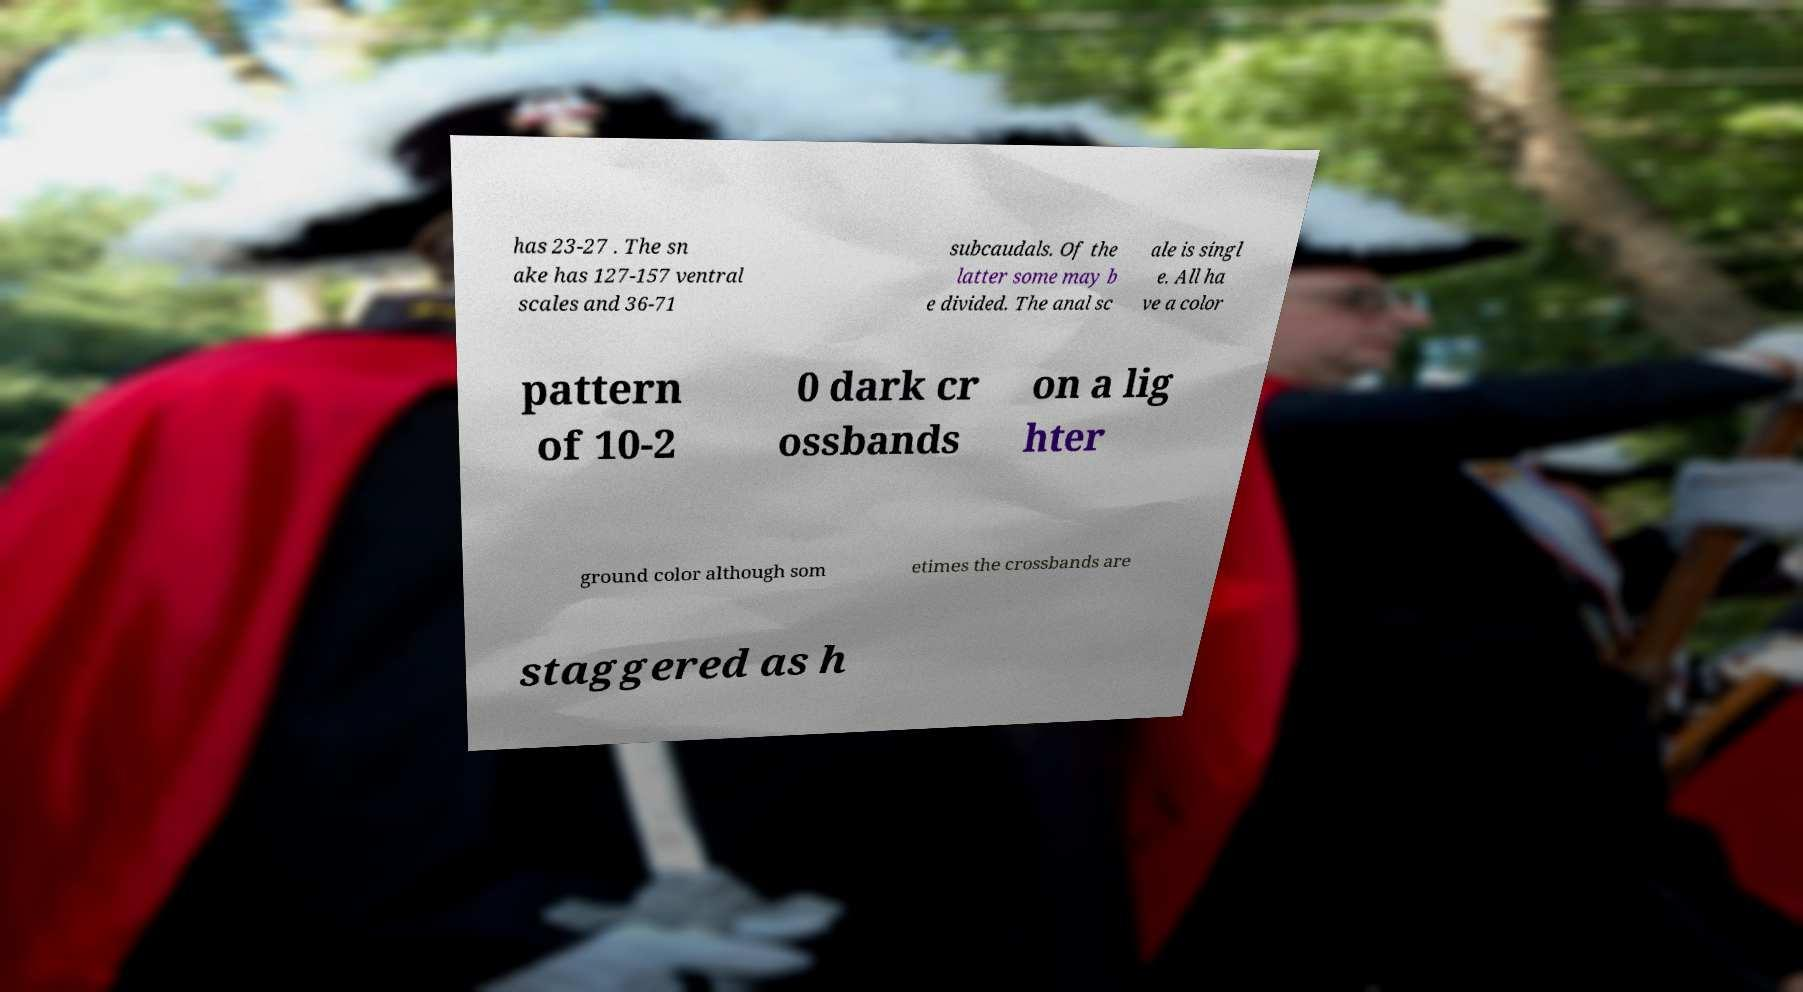Can you read and provide the text displayed in the image?This photo seems to have some interesting text. Can you extract and type it out for me? has 23-27 . The sn ake has 127-157 ventral scales and 36-71 subcaudals. Of the latter some may b e divided. The anal sc ale is singl e. All ha ve a color pattern of 10-2 0 dark cr ossbands on a lig hter ground color although som etimes the crossbands are staggered as h 